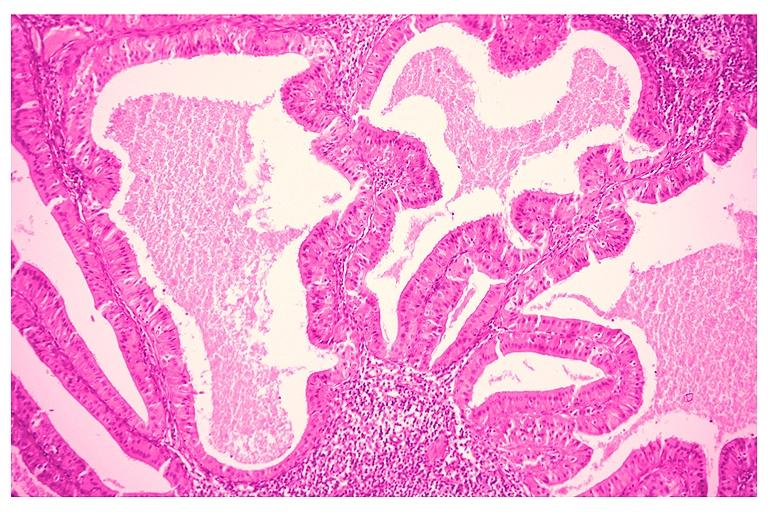does this image show papillary cystadenoma lymphomatosum warthins?
Answer the question using a single word or phrase. Yes 